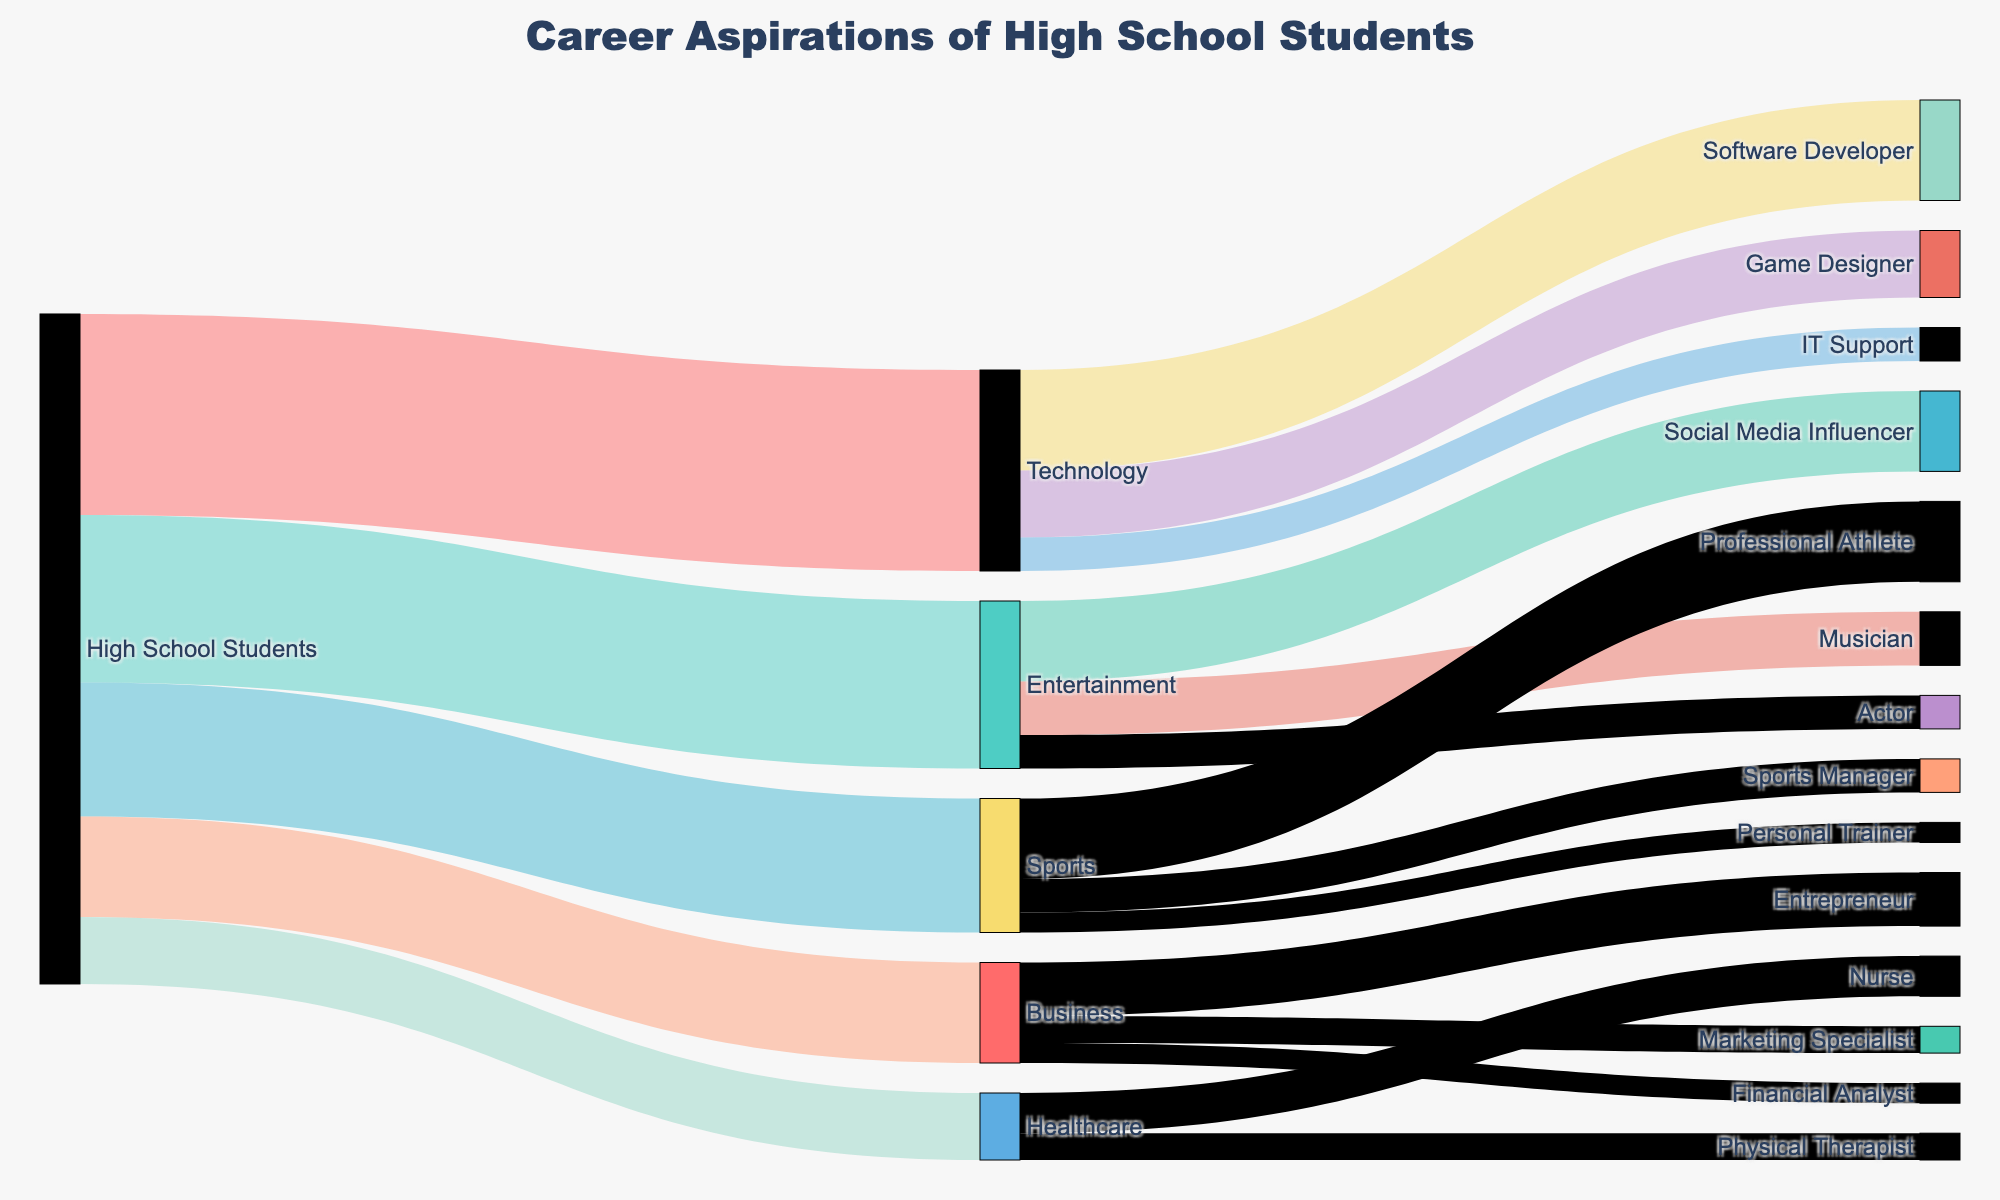What's the title of the Sankey diagram? The title is displayed prominently at the top of the figure and summarizes the main topic of the diagram.
Answer: Career Aspirations of High School Students Which industry has the most students interested in it? Check the first set of connections from "High School Students"; the one with the largest value indicates the most popular industry.
Answer: Technology How many students want to become Software Developers? Follow the connection from Technology to Software Developer and read the value indicated.
Answer: 15 What is the total number of students interested in the Healthcare industry? Identify all the links from High School Students to Healthcare and sum these values.
Answer: 10 Among the roles within entertainment, which one has the fewest students? Look at the connections from Entertainment and compare the values to identify the smallest one.
Answer: Actor How many students in total are interested in a career in Business? Sum the values from the link of High School Students to Business.
Answer: 15 Compare the number of students interested in Sports versus Business. Which has more? Sum the values of connections from High School Students to Sports, then separately to Business, and compare the totals.
Answer: Sports Calculate the total number of high school students represented in the diagram. Add up all the values from High School Students to the different industries (Technology, Entertainment, Sports, Business, Healthcare).
Answer: 100 How many more students want to be Social Media Influencers than Actors? Subtract the value for Actors (5) from the value for Social Media Influencers (12).
Answer: 7 Which job role in the Technology industry is the least popular, and how many students are interested in it? Compare the values for Software Developer, Game Designer, and IT Support, and identify the smallest one.
Answer: IT Support, 5 